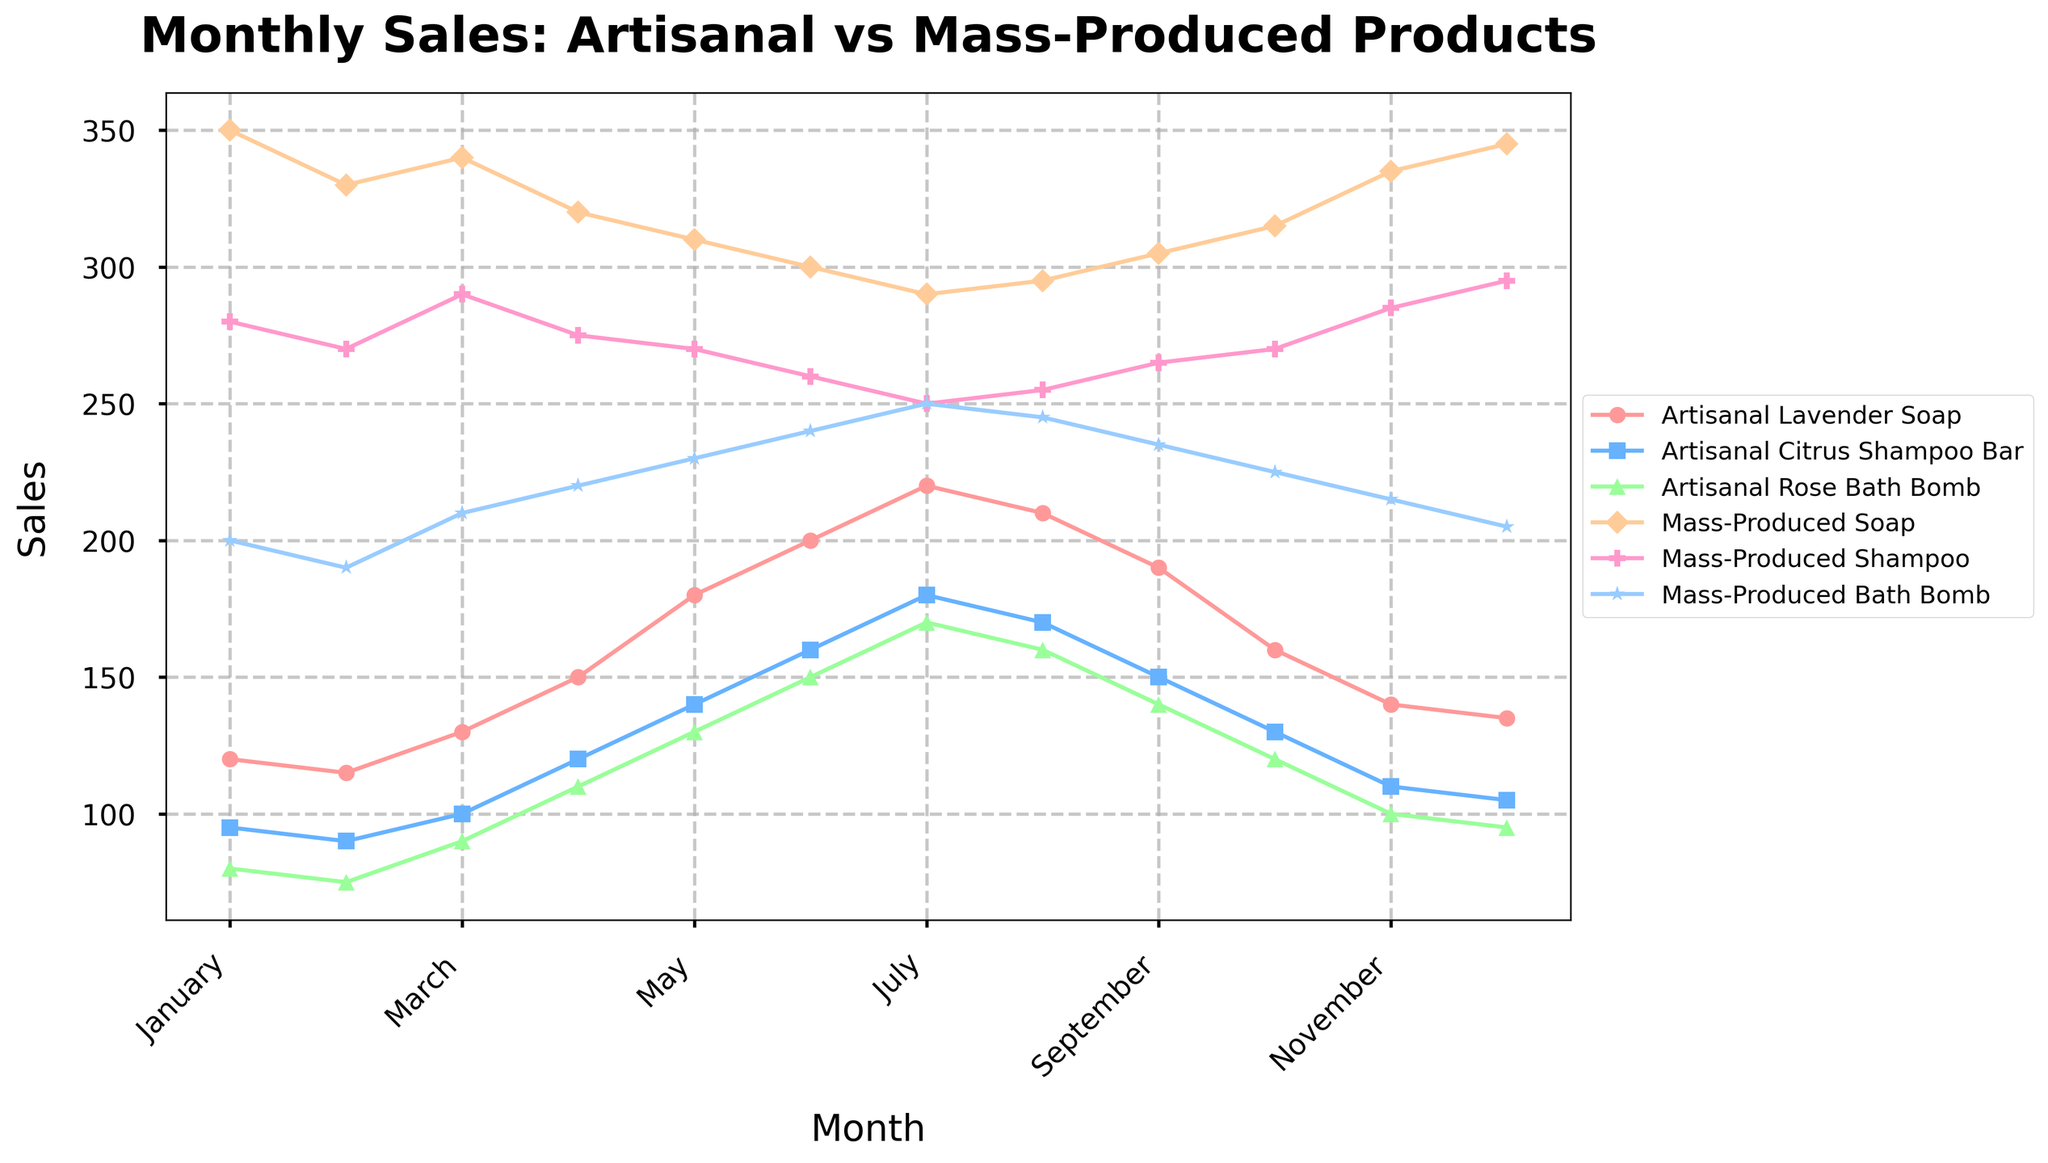What's the peak month for sales of Artisanal Lavender Soap? To find the peak month, identify the point where the line representing Artisanal Lavender Soap reaches its highest value. The month corresponding to this point is the peak month. Reviewing the chart, it's clear that sales of Artisanal Lavender Soap peak in July.
Answer: July In which month do Mass-Produced Soap sales drop to their lowest? Locate the lowest point on the line representing Mass-Produced Soap. The month corresponding to this point indicates when the sales are at their lowest. It is observed that the minimum sales for Mass-Produced Soap occur in July.
Answer: July What is the difference in sales between Artisanal Rose Bath Bomb and Mass-Produced Bath Bomb in June? Find the points for both Artisanal Rose Bath Bomb and Mass-Produced Bath Bomb in June on the chart. Note their sales figures and subtract the figure for Mass-Produced Bath Bomb from that of the Artisanal Rose Bath Bomb. In June, the sales figures are 150 for Artisanal Rose Bath Bomb and 240 for Mass-Produced Bath Bomb. The difference is 150 - 240 = -90.
Answer: -90 Compare the trends in sales for Artisanal Citrus Shampoo Bar and Mass-Produced Shampoo. Which one shows a more consistent trend throughout the year? By inspecting the lines on the chart, we look for the smoothness or fluctuation of both products' sales throughout the year. Artisanal Citrus Shampoo Bar shows a consistent increasing trend with less fluctuation compared to Mass-Produced Shampoo, which shows more variability.
Answer: Artisanal Citrus Shampoo Bar Are there any months where the sales of Artisanal and Mass-Produced Bath Bombs are equal? Look at the points where both the lines representing Artisanal and Mass-Produced Bath Bombs intersect. Observing the chart, it can be noted that there is no intersection between Artisanal and Mass-Produced Bath Bomb sales lines, indicating they are not equal in any month.
Answer: No What is the cumulative sales of Artisanal products in December? Add the sales figures for all Artisanal products (Lavender Soap, Citrus Shampoo Bar, Rose Bath Bomb) in December. Summing the figures: 135 + 105 + 95 = 335.
Answer: 335 During which quarter do Artisanal Lavender Soap sales increase the most? Divide the year into four quarters and then calculate the sales changes for Artisanal Lavender Soap within each quarter. The quarters are: Q1 (Jan-Mar), Q2 (Apr-Jun), Q3 (Jul-Sep), and Q4 (Oct-Dec). Comparing the changes in each quarter: Q1 (from 120 to 130), Q2 (from 150 to 200), Q3 (from 220 to 190), and Q4 (from 160 to 135), Q2 has the largest increase of 50 units.
Answer: Q2 Which product has the most sales in October, and what is the sales figure? Identify the product line that peaks the highest in October by comparing all the products. From the chart, Mass-Produced Soap has the highest sales in October with its sales figure indicated at 315.
Answer: Mass-Produced Soap, 315 How does the sales trend of Artisanal Rose Bath Bomb compare to that of Artisanal Citrus Shampoo Bar from August to December? Compare the slopes of the lines representing these products from August to December. The Artisanal Rose Bath Bomb's sales show a consistently decreasing trend, while Artisanal Citrus Shampoo Bar’s sales initially decline and then level off.
Answer: Rose Bath Bomb decreases, Citrus Shampoo Bar declines then levels off 